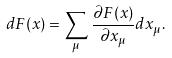<formula> <loc_0><loc_0><loc_500><loc_500>d F ( x ) = \sum _ { \mu } \, \frac { \partial F ( x ) } { \partial x _ { \mu } } d x _ { \mu } .</formula> 